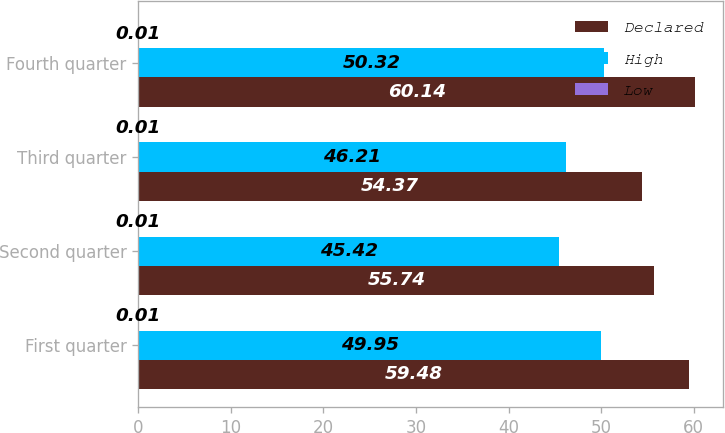<chart> <loc_0><loc_0><loc_500><loc_500><stacked_bar_chart><ecel><fcel>First quarter<fcel>Second quarter<fcel>Third quarter<fcel>Fourth quarter<nl><fcel>Declared<fcel>59.48<fcel>55.74<fcel>54.37<fcel>60.14<nl><fcel>High<fcel>49.95<fcel>45.42<fcel>46.21<fcel>50.32<nl><fcel>Low<fcel>0.01<fcel>0.01<fcel>0.01<fcel>0.01<nl></chart> 